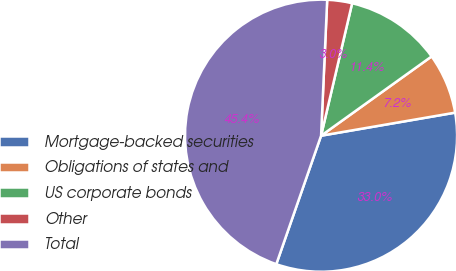<chart> <loc_0><loc_0><loc_500><loc_500><pie_chart><fcel>Mortgage-backed securities<fcel>Obligations of states and<fcel>US corporate bonds<fcel>Other<fcel>Total<nl><fcel>33.05%<fcel>7.19%<fcel>11.43%<fcel>2.95%<fcel>45.38%<nl></chart> 